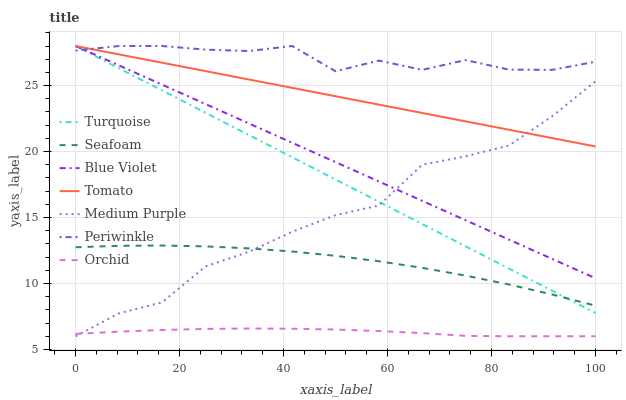Does Orchid have the minimum area under the curve?
Answer yes or no. Yes. Does Periwinkle have the maximum area under the curve?
Answer yes or no. Yes. Does Turquoise have the minimum area under the curve?
Answer yes or no. No. Does Turquoise have the maximum area under the curve?
Answer yes or no. No. Is Tomato the smoothest?
Answer yes or no. Yes. Is Medium Purple the roughest?
Answer yes or no. Yes. Is Turquoise the smoothest?
Answer yes or no. No. Is Turquoise the roughest?
Answer yes or no. No. Does Medium Purple have the lowest value?
Answer yes or no. Yes. Does Turquoise have the lowest value?
Answer yes or no. No. Does Blue Violet have the highest value?
Answer yes or no. Yes. Does Seafoam have the highest value?
Answer yes or no. No. Is Orchid less than Turquoise?
Answer yes or no. Yes. Is Periwinkle greater than Medium Purple?
Answer yes or no. Yes. Does Turquoise intersect Tomato?
Answer yes or no. Yes. Is Turquoise less than Tomato?
Answer yes or no. No. Is Turquoise greater than Tomato?
Answer yes or no. No. Does Orchid intersect Turquoise?
Answer yes or no. No. 